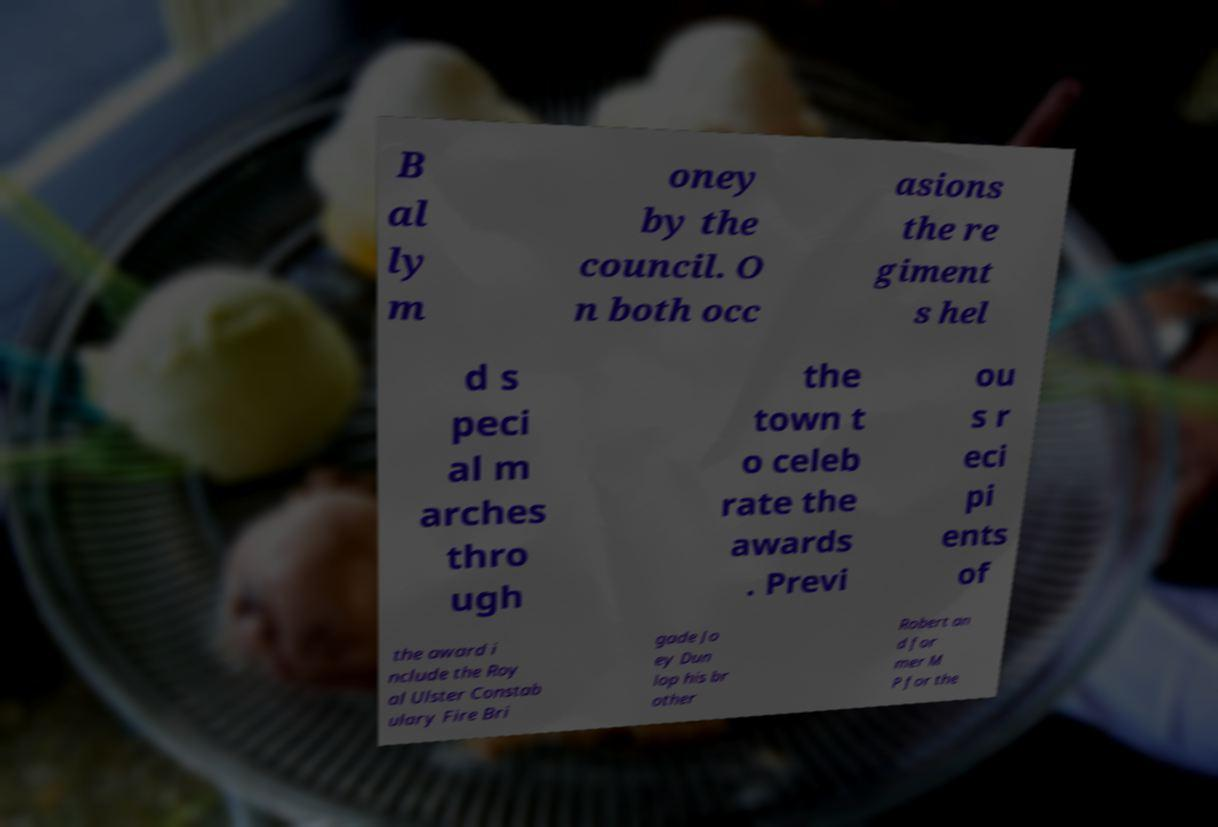Please identify and transcribe the text found in this image. B al ly m oney by the council. O n both occ asions the re giment s hel d s peci al m arches thro ugh the town t o celeb rate the awards . Previ ou s r eci pi ents of the award i nclude the Roy al Ulster Constab ulary Fire Bri gade Jo ey Dun lop his br other Robert an d for mer M P for the 